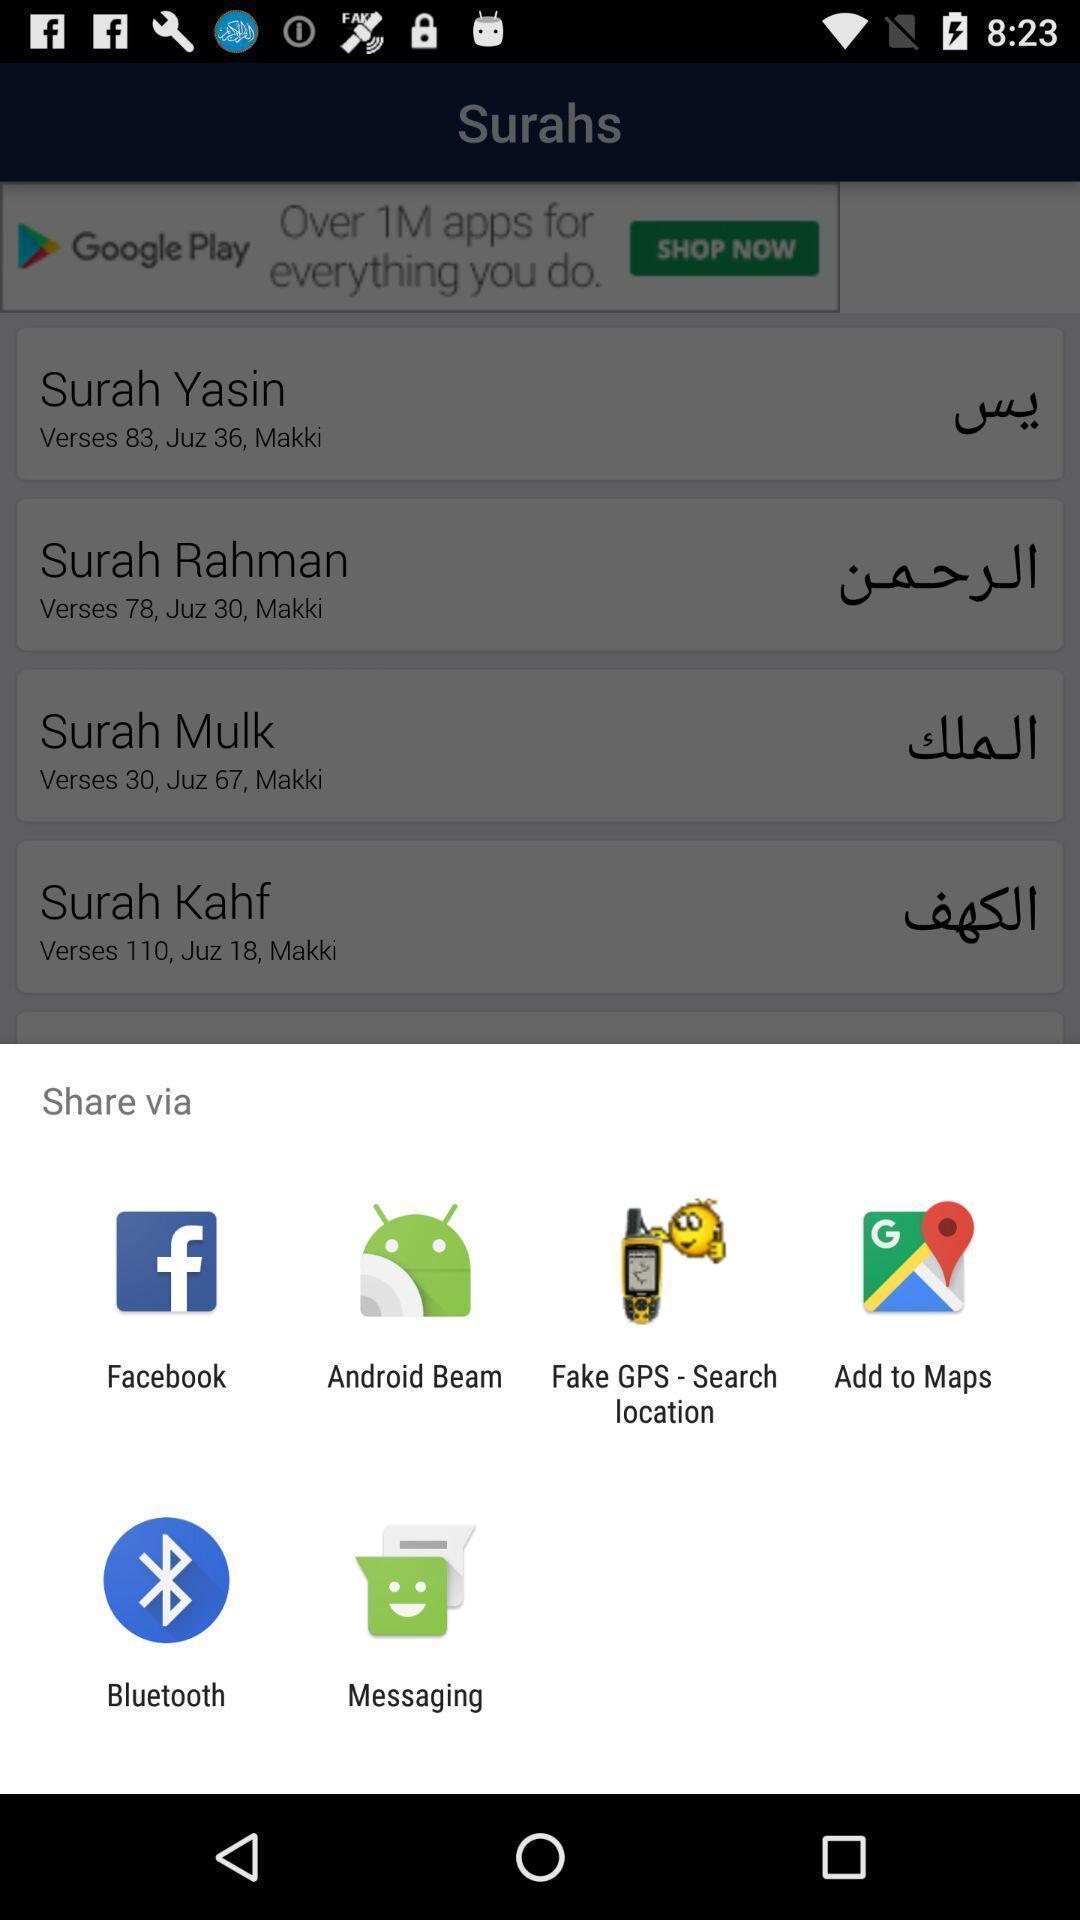What can you discern from this picture? Pop up window of screen options. 